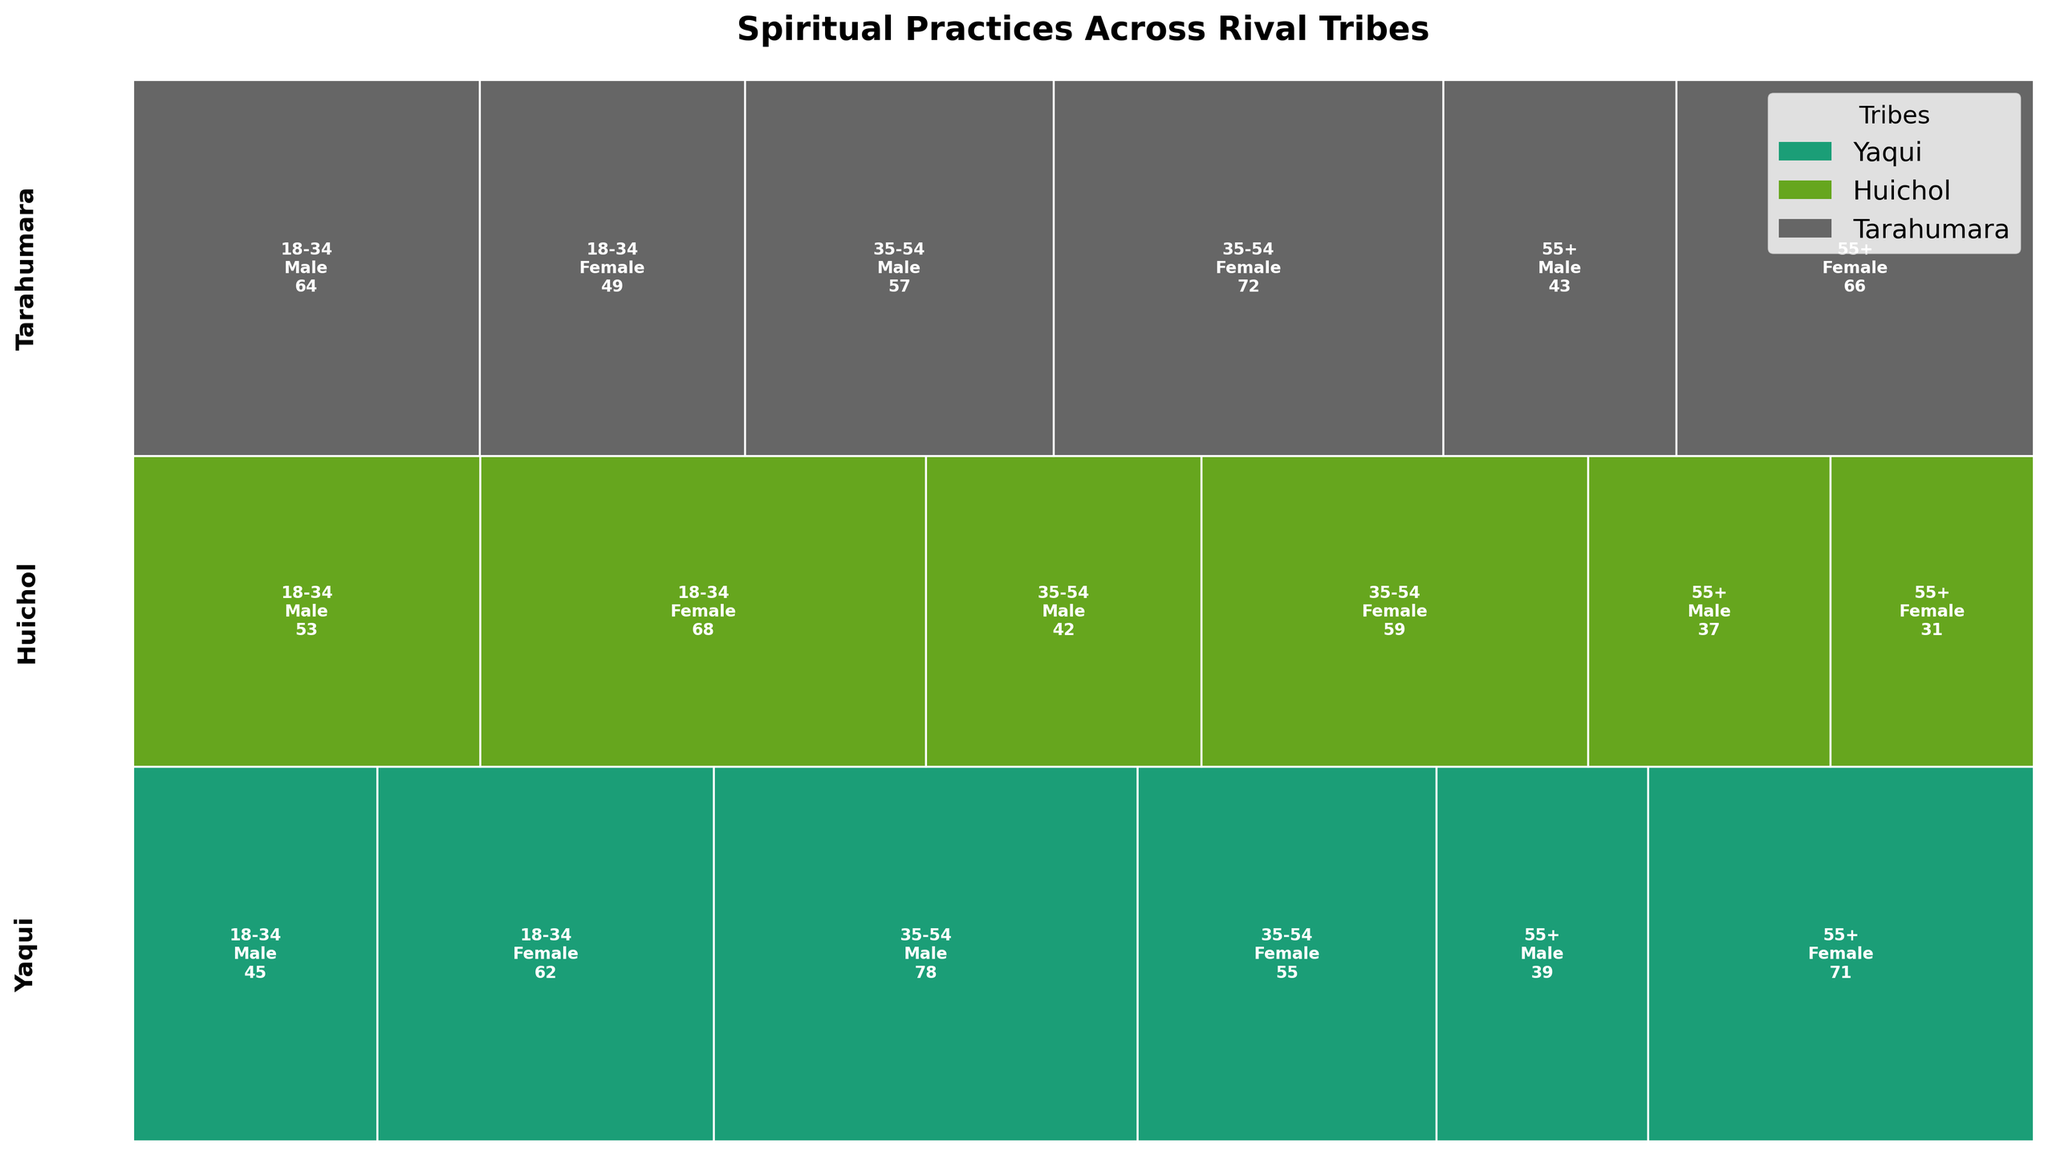Which tribe has the highest overall count of spiritual practices? To determine the tribe with the highest overall count, sum the counts for each tribe and compare. Yaqui has a total count of 350, Huichol has 290, and Tarahumara has 351.
Answer: Tarahumara Which spiritual practice among the Huichol 18-34 females has the highest count? Check the counts of spiritual practices listed under Huichol for the 18-34 female age and gender group. Eye of God Weaving has the highest count with 68.
Answer: Eye of God Weaving What is the combined count of spiritual practices for Yaqui males aged 18-34 and 35-54? Add the counts for Vision Quest (45) and Peyote Ceremony (78) for Yaqui males in the age groups 18-34 and 35-54. 45 + 78 = 123.
Answer: 123 Which gender has more participants in the Yaqui tribe for the age group 55+? Compare the counts of spiritual practices for males and females aged 55+ in the Yaqui tribe. Females have 71 for Smudging, and males have 39 for Sweat Lodge.
Answer: Females Is the number of spiritual practices higher for Yaqui females aged 35-54 or Tarahumara females aged 35-54? Compare the counts: Yaqui females aged 35-54 have 55 for Talking Circle, while Tarahumara females aged 35-54 have 72 for Matachines Dance.
Answer: Tarahumara females aged 35-54 Which tribe has the least overall count of spiritual practices for males aged 55+? Compare the counts among males aged 55+ in each tribe. Yaqui has 39, Huichol has 37, and Tarahumara has 43.
Answer: Huichol What is the total count of spiritual practices for females across all tribes aged 18-34? Sum the counts of spiritual practices for females aged 18-34 in all tribes. Yaqui: 62, Huichol: 68, Tarahumara: 49. 62 + 68 + 49 = 179.
Answer: 179 Comparing males aged 35-54, which spiritual practice has the highest count and in which tribe? Compare the counts of spiritual practices for males aged 35-54 across all tribes. Peyote Ceremony in Yaqui has 78, Corn Blessing in Huichol has 42, Raspa Ceremony in Tarahumara has 57.
Answer: Peyote Ceremony in Yaqui 